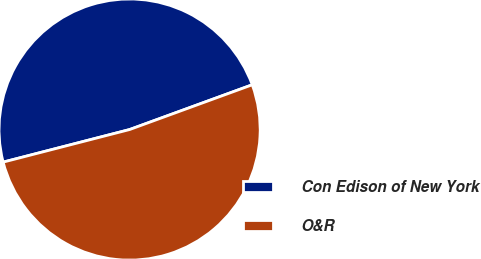<chart> <loc_0><loc_0><loc_500><loc_500><pie_chart><fcel>Con Edison of New York<fcel>O&R<nl><fcel>48.44%<fcel>51.56%<nl></chart> 